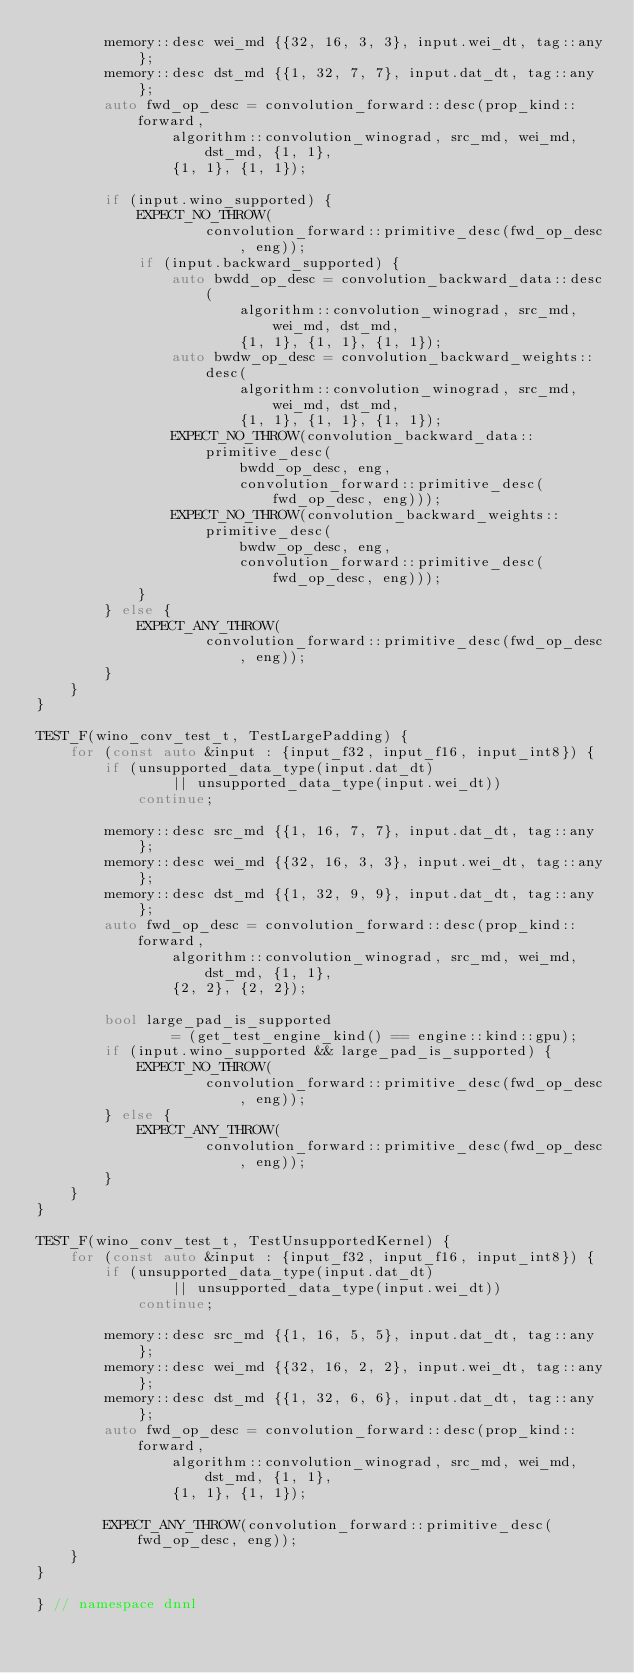Convert code to text. <code><loc_0><loc_0><loc_500><loc_500><_C++_>        memory::desc wei_md {{32, 16, 3, 3}, input.wei_dt, tag::any};
        memory::desc dst_md {{1, 32, 7, 7}, input.dat_dt, tag::any};
        auto fwd_op_desc = convolution_forward::desc(prop_kind::forward,
                algorithm::convolution_winograd, src_md, wei_md, dst_md, {1, 1},
                {1, 1}, {1, 1});

        if (input.wino_supported) {
            EXPECT_NO_THROW(
                    convolution_forward::primitive_desc(fwd_op_desc, eng));
            if (input.backward_supported) {
                auto bwdd_op_desc = convolution_backward_data::desc(
                        algorithm::convolution_winograd, src_md, wei_md, dst_md,
                        {1, 1}, {1, 1}, {1, 1});
                auto bwdw_op_desc = convolution_backward_weights::desc(
                        algorithm::convolution_winograd, src_md, wei_md, dst_md,
                        {1, 1}, {1, 1}, {1, 1});
                EXPECT_NO_THROW(convolution_backward_data::primitive_desc(
                        bwdd_op_desc, eng,
                        convolution_forward::primitive_desc(fwd_op_desc, eng)));
                EXPECT_NO_THROW(convolution_backward_weights::primitive_desc(
                        bwdw_op_desc, eng,
                        convolution_forward::primitive_desc(fwd_op_desc, eng)));
            }
        } else {
            EXPECT_ANY_THROW(
                    convolution_forward::primitive_desc(fwd_op_desc, eng));
        }
    }
}

TEST_F(wino_conv_test_t, TestLargePadding) {
    for (const auto &input : {input_f32, input_f16, input_int8}) {
        if (unsupported_data_type(input.dat_dt)
                || unsupported_data_type(input.wei_dt))
            continue;

        memory::desc src_md {{1, 16, 7, 7}, input.dat_dt, tag::any};
        memory::desc wei_md {{32, 16, 3, 3}, input.wei_dt, tag::any};
        memory::desc dst_md {{1, 32, 9, 9}, input.dat_dt, tag::any};
        auto fwd_op_desc = convolution_forward::desc(prop_kind::forward,
                algorithm::convolution_winograd, src_md, wei_md, dst_md, {1, 1},
                {2, 2}, {2, 2});

        bool large_pad_is_supported
                = (get_test_engine_kind() == engine::kind::gpu);
        if (input.wino_supported && large_pad_is_supported) {
            EXPECT_NO_THROW(
                    convolution_forward::primitive_desc(fwd_op_desc, eng));
        } else {
            EXPECT_ANY_THROW(
                    convolution_forward::primitive_desc(fwd_op_desc, eng));
        }
    }
}

TEST_F(wino_conv_test_t, TestUnsupportedKernel) {
    for (const auto &input : {input_f32, input_f16, input_int8}) {
        if (unsupported_data_type(input.dat_dt)
                || unsupported_data_type(input.wei_dt))
            continue;

        memory::desc src_md {{1, 16, 5, 5}, input.dat_dt, tag::any};
        memory::desc wei_md {{32, 16, 2, 2}, input.wei_dt, tag::any};
        memory::desc dst_md {{1, 32, 6, 6}, input.dat_dt, tag::any};
        auto fwd_op_desc = convolution_forward::desc(prop_kind::forward,
                algorithm::convolution_winograd, src_md, wei_md, dst_md, {1, 1},
                {1, 1}, {1, 1});

        EXPECT_ANY_THROW(convolution_forward::primitive_desc(fwd_op_desc, eng));
    }
}

} // namespace dnnl
</code> 